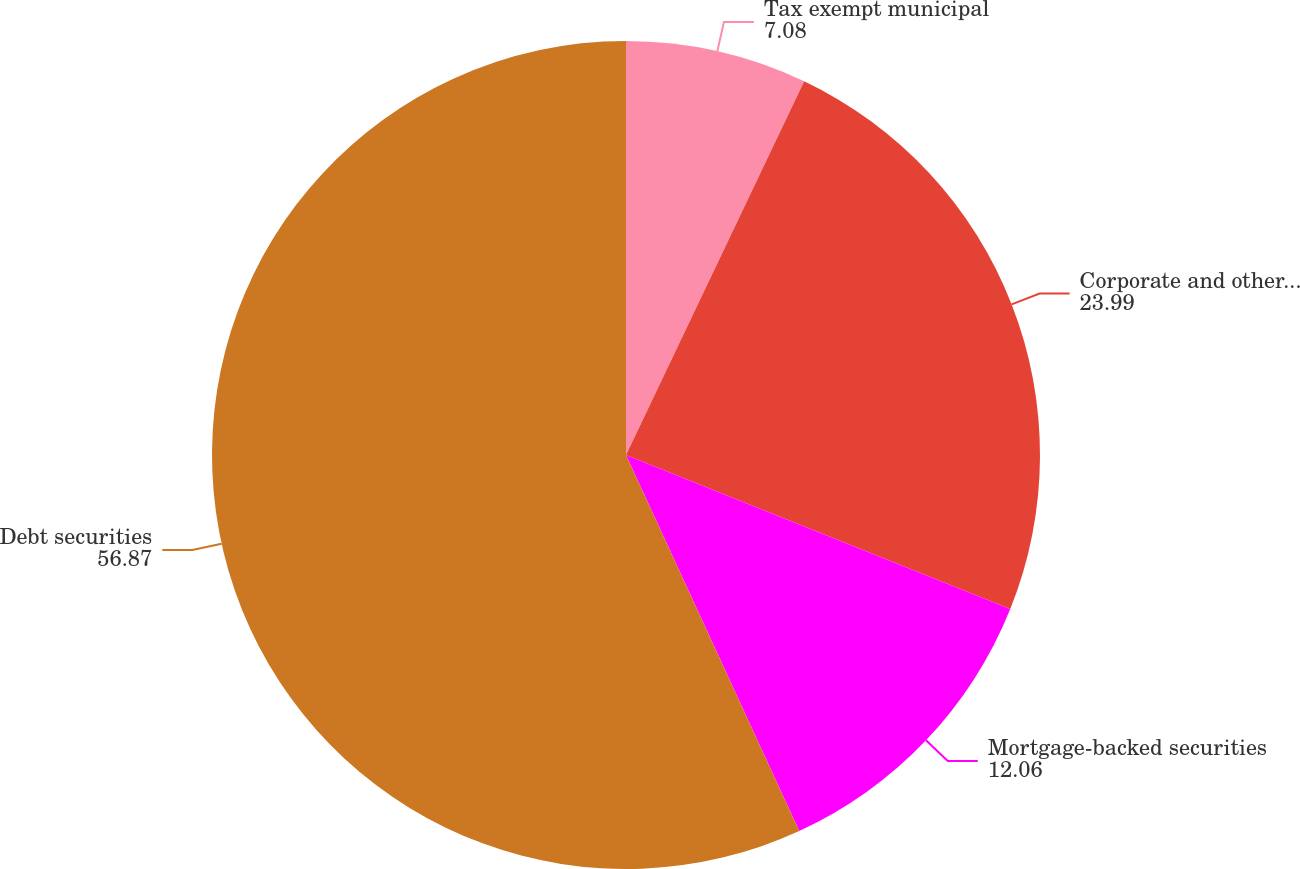<chart> <loc_0><loc_0><loc_500><loc_500><pie_chart><fcel>Tax exempt municipal<fcel>Corporate and other securities<fcel>Mortgage-backed securities<fcel>Debt securities<nl><fcel>7.08%<fcel>23.99%<fcel>12.06%<fcel>56.87%<nl></chart> 